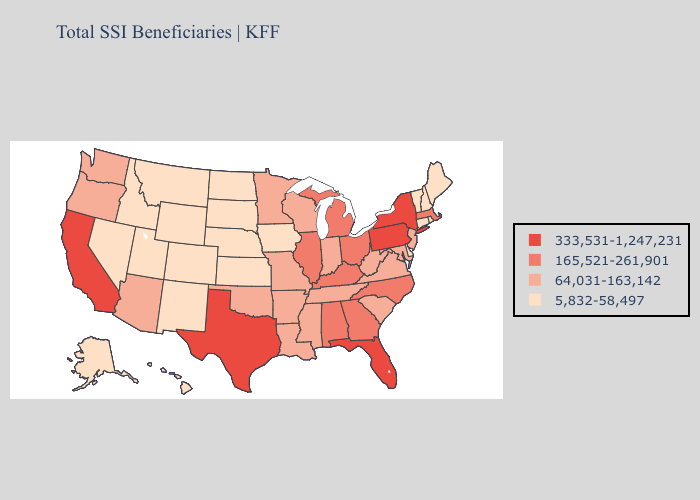What is the highest value in states that border Arizona?
Give a very brief answer. 333,531-1,247,231. Does South Carolina have the highest value in the USA?
Concise answer only. No. Does Iowa have a higher value than North Carolina?
Give a very brief answer. No. What is the value of Nebraska?
Answer briefly. 5,832-58,497. Name the states that have a value in the range 64,031-163,142?
Answer briefly. Arizona, Arkansas, Indiana, Louisiana, Maryland, Minnesota, Mississippi, Missouri, New Jersey, Oklahoma, Oregon, South Carolina, Tennessee, Virginia, Washington, West Virginia, Wisconsin. Which states hav the highest value in the Northeast?
Concise answer only. New York, Pennsylvania. Among the states that border North Dakota , which have the highest value?
Quick response, please. Minnesota. What is the value of South Carolina?
Keep it brief. 64,031-163,142. Is the legend a continuous bar?
Be succinct. No. Name the states that have a value in the range 333,531-1,247,231?
Keep it brief. California, Florida, New York, Pennsylvania, Texas. What is the lowest value in the USA?
Write a very short answer. 5,832-58,497. Name the states that have a value in the range 5,832-58,497?
Short answer required. Alaska, Colorado, Connecticut, Delaware, Hawaii, Idaho, Iowa, Kansas, Maine, Montana, Nebraska, Nevada, New Hampshire, New Mexico, North Dakota, Rhode Island, South Dakota, Utah, Vermont, Wyoming. Which states have the highest value in the USA?
Quick response, please. California, Florida, New York, Pennsylvania, Texas. Among the states that border Pennsylvania , which have the lowest value?
Concise answer only. Delaware. Does Ohio have the lowest value in the MidWest?
Answer briefly. No. 